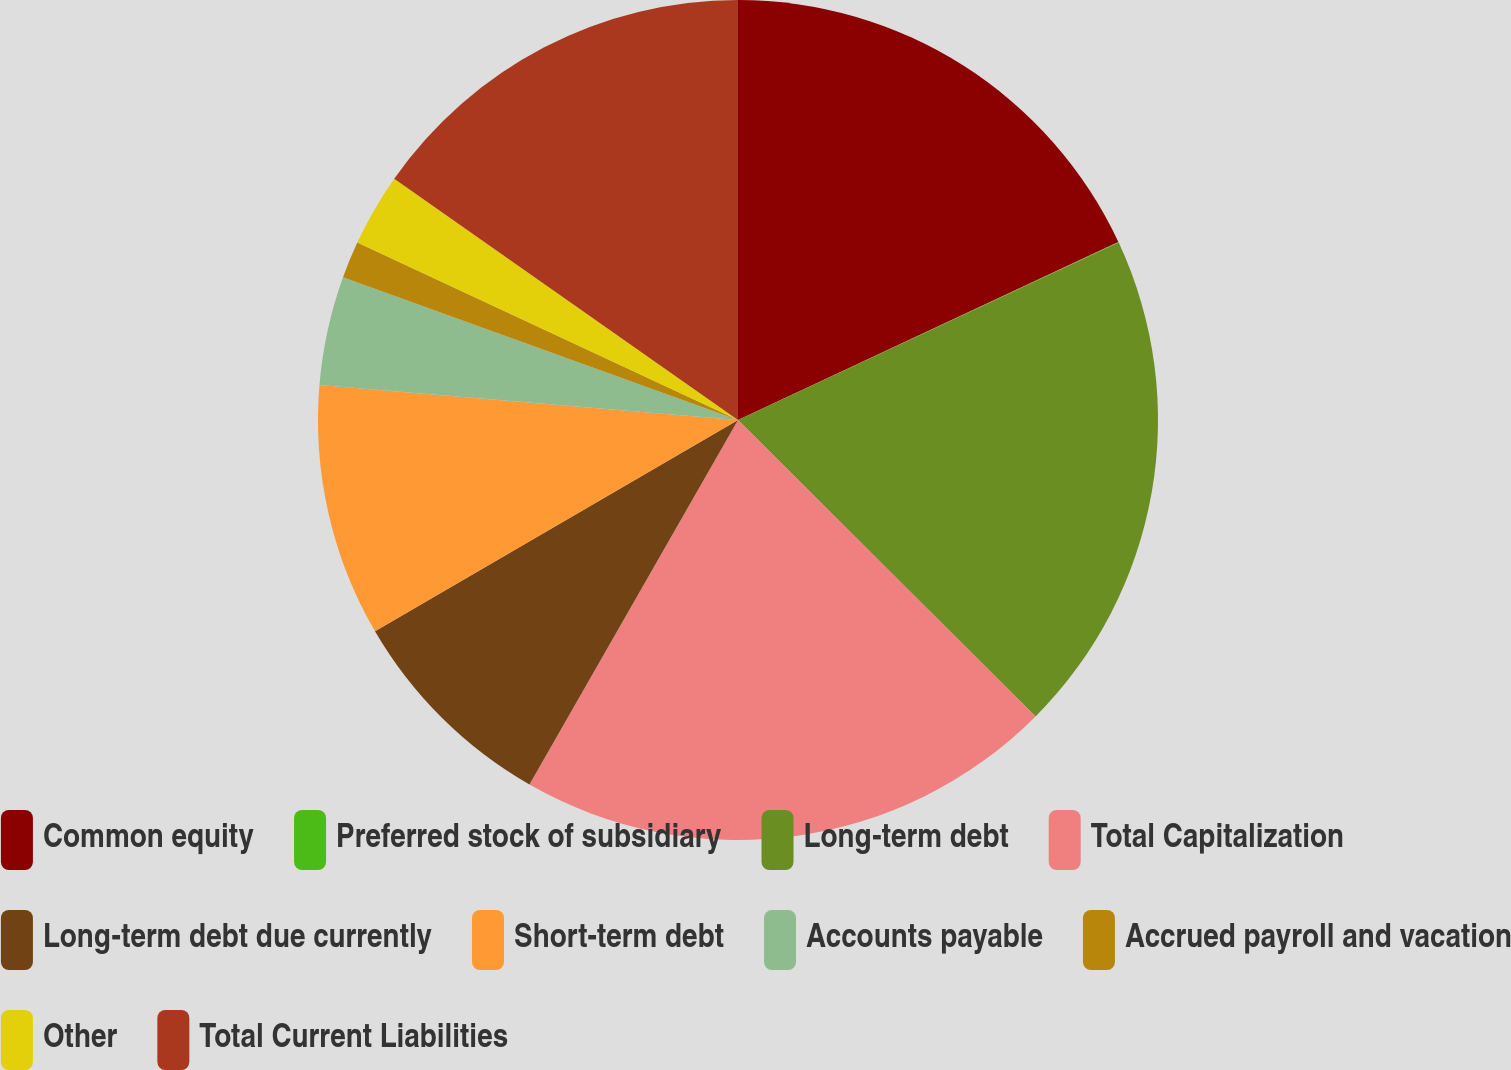Convert chart to OTSL. <chart><loc_0><loc_0><loc_500><loc_500><pie_chart><fcel>Common equity<fcel>Preferred stock of subsidiary<fcel>Long-term debt<fcel>Total Capitalization<fcel>Long-term debt due currently<fcel>Short-term debt<fcel>Accounts payable<fcel>Accrued payroll and vacation<fcel>Other<fcel>Total Current Liabilities<nl><fcel>18.03%<fcel>0.03%<fcel>19.41%<fcel>20.8%<fcel>8.34%<fcel>9.72%<fcel>4.19%<fcel>1.42%<fcel>2.8%<fcel>15.26%<nl></chart> 